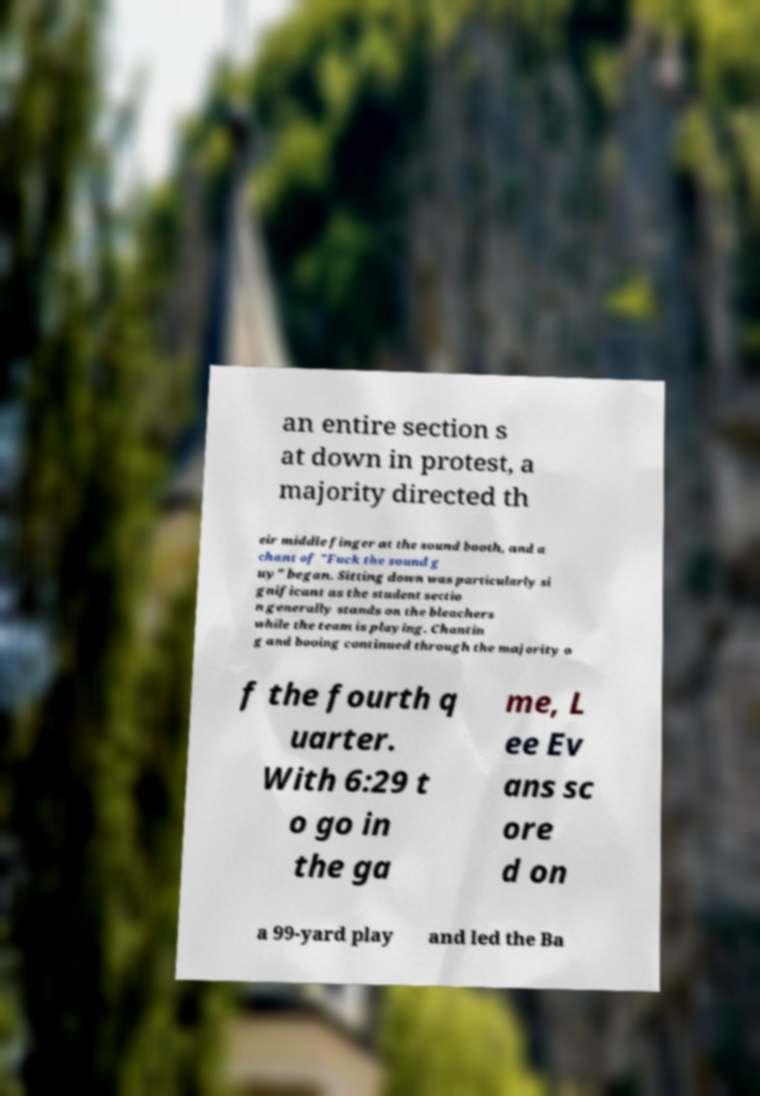What messages or text are displayed in this image? I need them in a readable, typed format. an entire section s at down in protest, a majority directed th eir middle finger at the sound booth, and a chant of "Fuck the sound g uy" began. Sitting down was particularly si gnificant as the student sectio n generally stands on the bleachers while the team is playing. Chantin g and booing continued through the majority o f the fourth q uarter. With 6:29 t o go in the ga me, L ee Ev ans sc ore d on a 99-yard play and led the Ba 